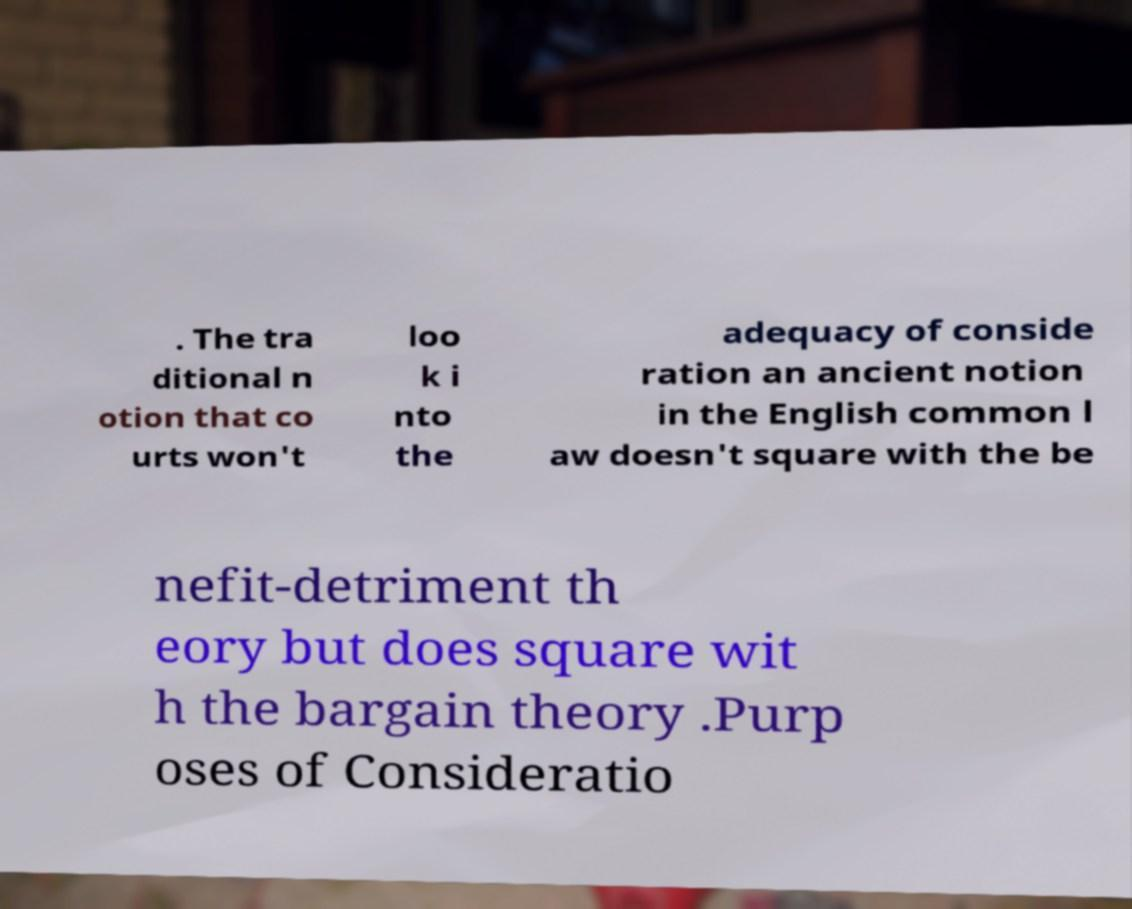Could you assist in decoding the text presented in this image and type it out clearly? . The tra ditional n otion that co urts won't loo k i nto the adequacy of conside ration an ancient notion in the English common l aw doesn't square with the be nefit-detriment th eory but does square wit h the bargain theory .Purp oses of Consideratio 